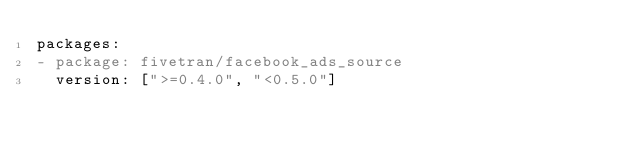<code> <loc_0><loc_0><loc_500><loc_500><_YAML_>packages:
- package: fivetran/facebook_ads_source
  version: [">=0.4.0", "<0.5.0"]
</code> 